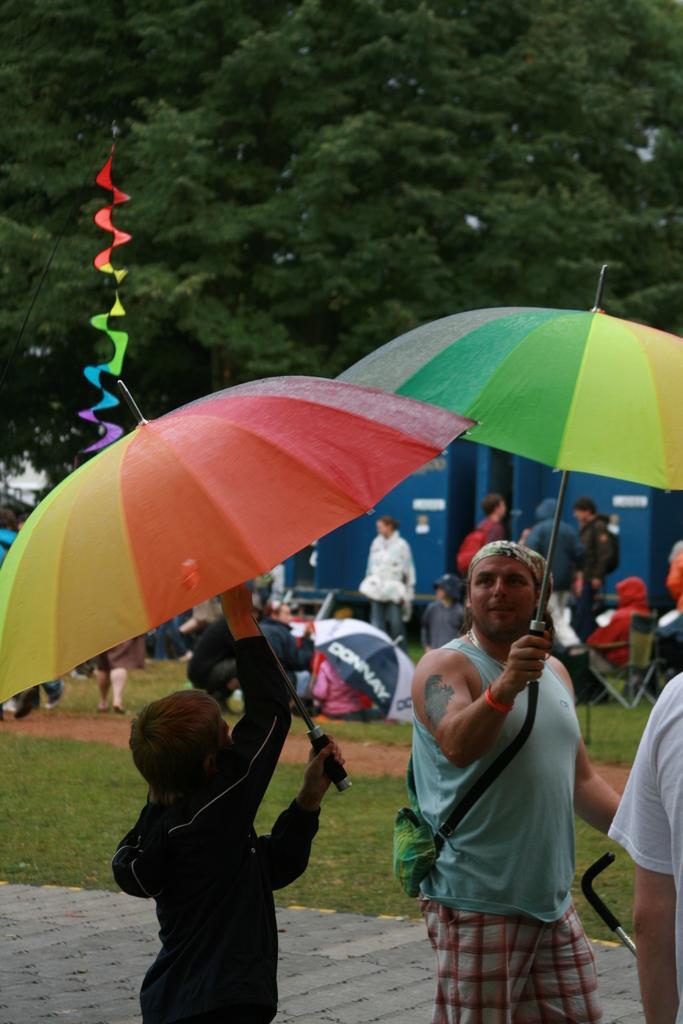How would you summarize this image in a sentence or two? This image is taken outdoors. At the bottom of the image there is a sidewalk and a ground with grass on it. At the top of the image there are a few trees. In the middle of the image a few people are sitting on the chairs, a few are standing and a few are sitting on the ground and a vehicle is parked on the ground. A few people are standing on the ground and holding umbrellas in their hands. 